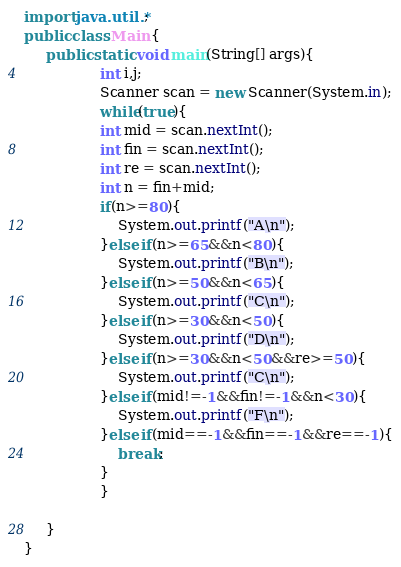Convert code to text. <code><loc_0><loc_0><loc_500><loc_500><_Java_>import java.util.*;
public class Main {
	 public static void main(String[] args){
		         int i,j;
		         Scanner scan = new Scanner(System.in);
		         while(true){
		         int mid = scan.nextInt();
		         int fin = scan.nextInt();
		         int re = scan.nextInt();
		         int n = fin+mid;
	             if(n>=80){
	            	 System.out.printf("A\n");
	             }else if(n>=65&&n<80){
	            	 System.out.printf("B\n");
	             }else if(n>=50&&n<65){
	            	 System.out.printf("C\n");
	             }else if(n>=30&&n<50){
	            	 System.out.printf("D\n");
	             }else if(n>=30&&n<50&&re>=50){
	            	 System.out.printf("C\n");
	             }else if(mid!=-1&&fin!=-1&&n<30){
	            	 System.out.printf("F\n");
	             }else if(mid==-1&&fin==-1&&re==-1){
	            	 break;
	             }
		         }
		         
	 }
}</code> 